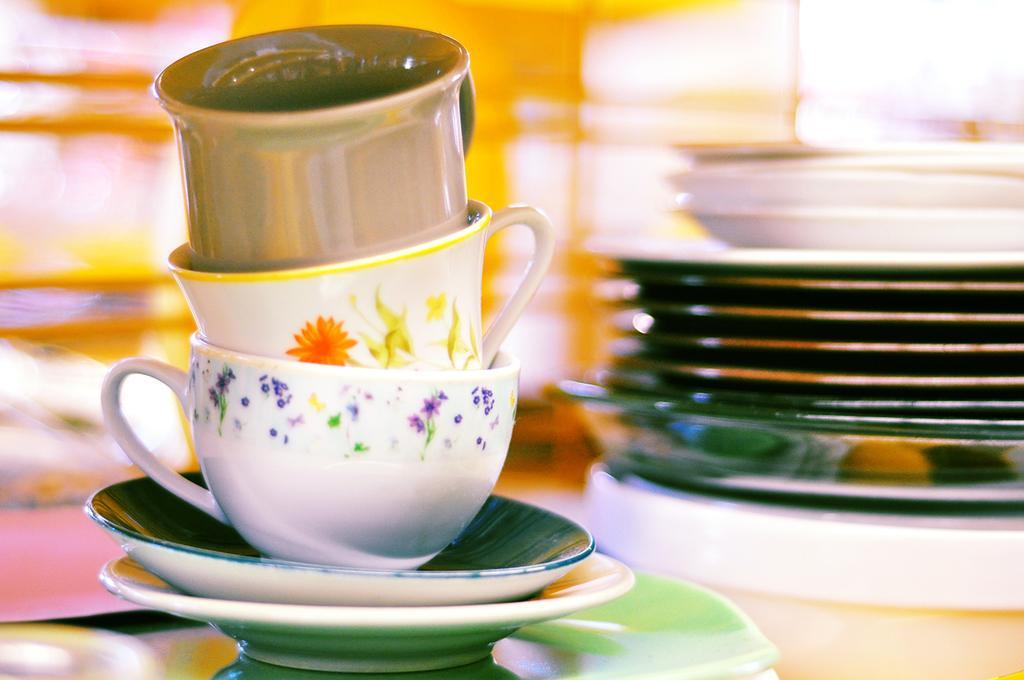How would you summarize this image in a sentence or two? In this picture we can see three cups, saucers and plates, we can see a blurry background. 